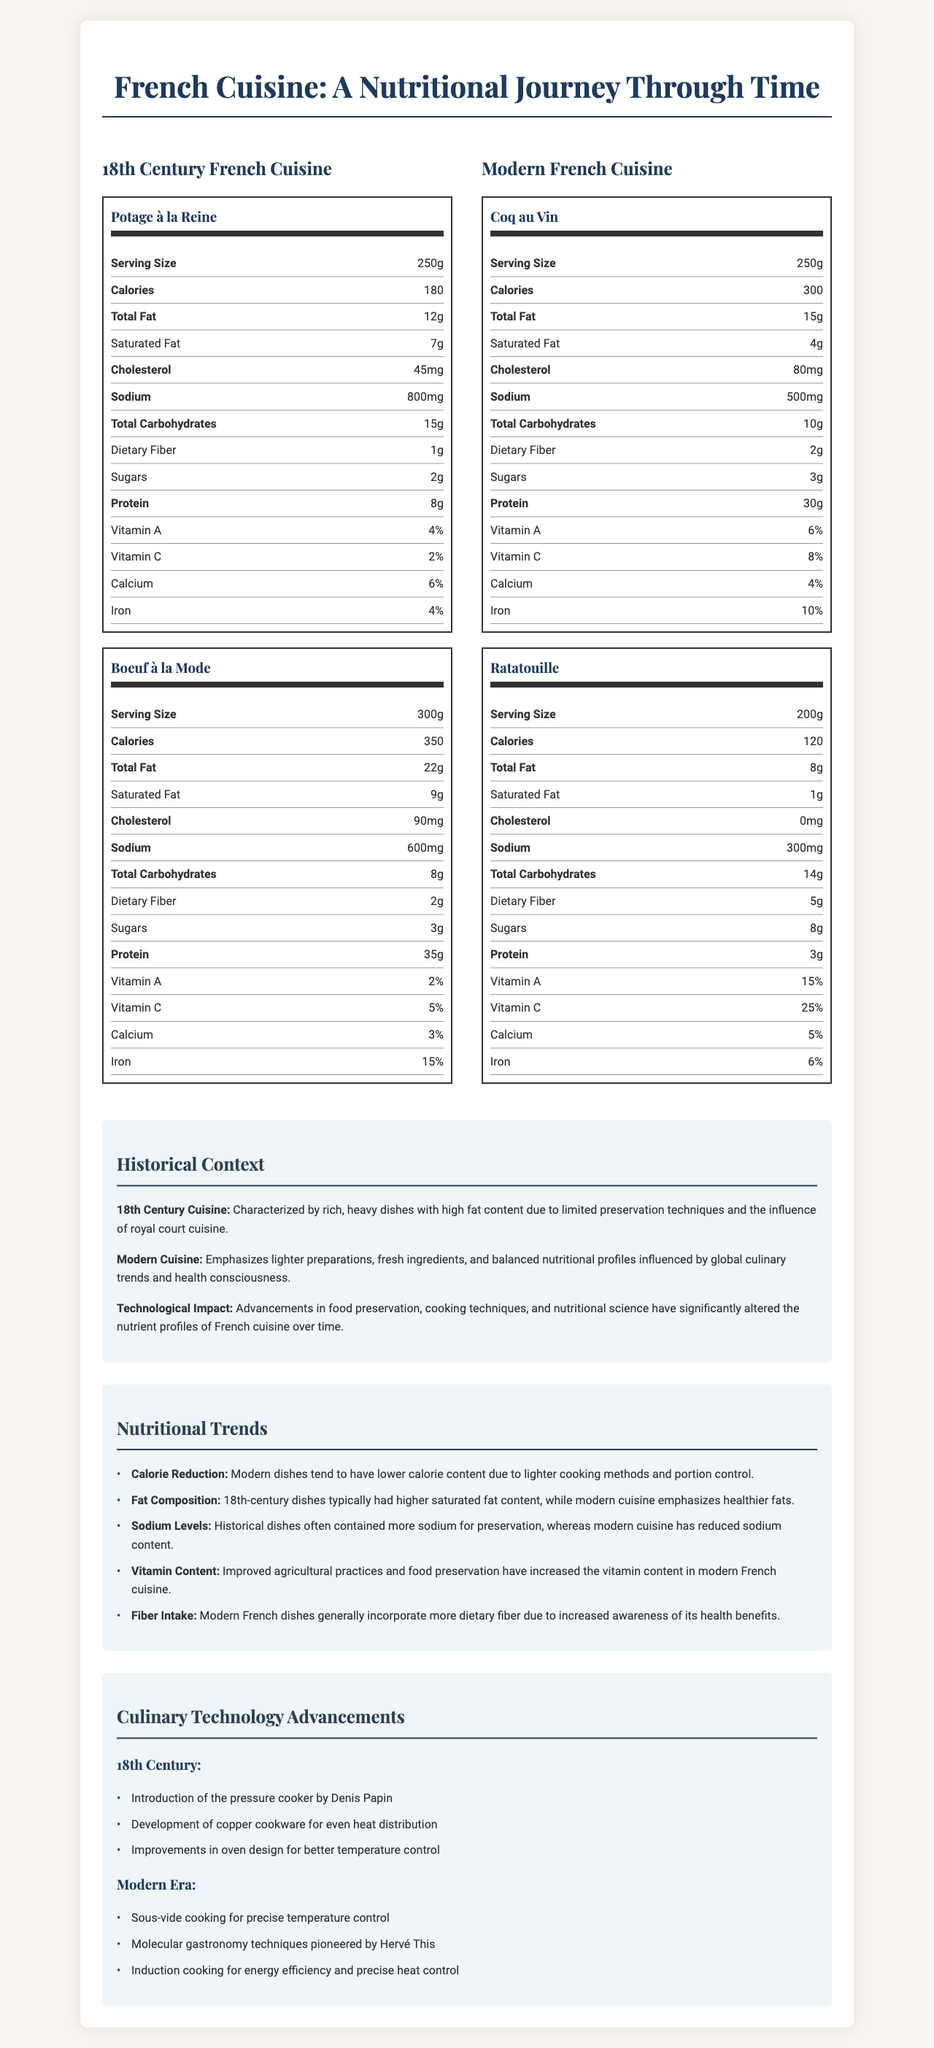what is the serving size of Potage à la Reine? The serving size of Potage à la Reine is listed as 250g in the nutrition label for 18th-century French cuisine.
Answer: 250g how many calories are in a serving of Boeuf à la Mode? The nutrition label for Boeuf à la Mode indicates that it contains 350 calories per serving.
Answer: 350 calories which dish has the highest protein content? Coq au Vin has 30g of protein per serving, which is the highest among the listed dishes.
Answer: Coq au Vin what is the sodium content of Ratatouille? According to the nutrition label for modern French cuisine, Ratatouille contains 300mg of sodium per serving.
Answer: 300mg what percentage of daily Vitamin C does a serving of Ratatouille provide? The nutrition label for Ratatouille shows that it provides 25% of the daily Vitamin C intake.
Answer: 25% Which dish has the highest amount of saturated fat? A. Potage à la Reine B. Boeuf à la Mode C. Coq au Vin D. Ratatouille Potage à la Reine has 7g of saturated fat, which is the highest among the listed dishes.
Answer: A Which of the following has the lowest calorie content? I. Potage à la Reine II. Coq au Vin III. Ratatouille IV. Boeuf à la Mode Ratatouille has the lowest calorie content at 120 calories per serving.
Answer: III Is the fat composition in modern French cuisine healthier than in 18th-century French cuisine? Modern French cuisine emphasizes healthier fats with lower saturated fat content compared to the 18th-century French cuisine, as noted in the nutritional trends section.
Answer: Yes Summarize the main idea of the document. This summary encompasses the detailed nutritional comparisons, historical context, and technological impacts provided in the document.
Answer: The document provides a comparative analysis of nutrient profiles in 18th-century French cuisine versus modern French dishes. It highlights differences in calorie content, fat composition, sodium levels, vitamin content, and dietary fiber, with historical context and explanations of culinary technology advancements. Which one of the technological advancements introduced in the 18th century is most commonly used in modern cuisine? The document lists technological advancements but does not specify which 18th-century technologies are most commonly used in modern cuisine, making it impossible to determine this from the visual information provided.
Answer: Not enough information What are the main factors driving nutritional changes in French cuisine from the 18th century to the modern era? The document explains that advancements in food preservation and cooking techniques, along with increased health consciousness and global culinary trends, have significantly influenced the nutrient profiles in modern French cuisine compared to the 18th century.
Answer: Technological advancements, health consciousness, and global culinary influences. 